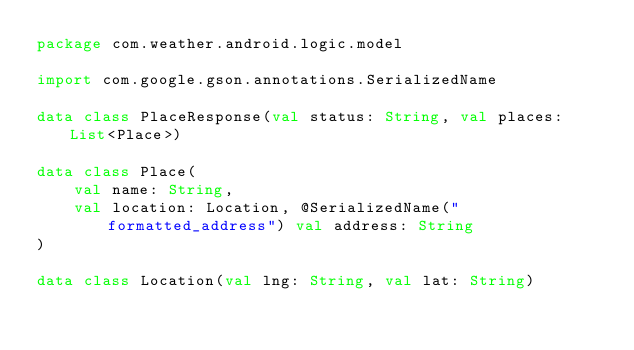Convert code to text. <code><loc_0><loc_0><loc_500><loc_500><_Kotlin_>package com.weather.android.logic.model

import com.google.gson.annotations.SerializedName

data class PlaceResponse(val status: String, val places: List<Place>)

data class Place(
    val name: String,
    val location: Location, @SerializedName("formatted_address") val address: String
)

data class Location(val lng: String, val lat: String)</code> 